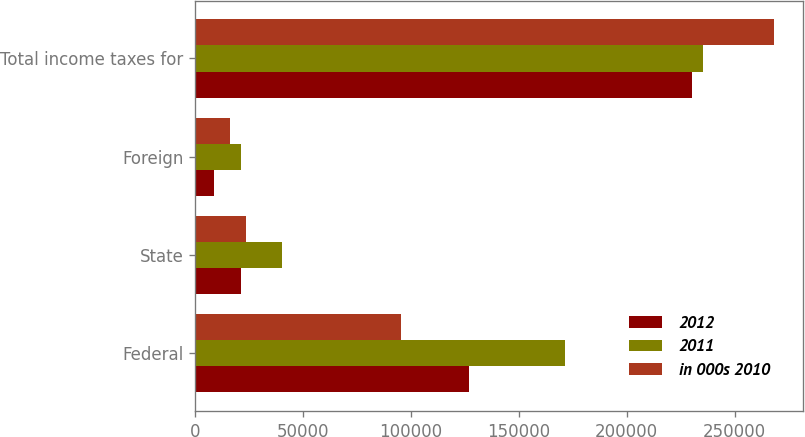Convert chart. <chart><loc_0><loc_0><loc_500><loc_500><stacked_bar_chart><ecel><fcel>Federal<fcel>State<fcel>Foreign<fcel>Total income taxes for<nl><fcel>2012<fcel>126773<fcel>21285<fcel>8647<fcel>230102<nl><fcel>2011<fcel>171337<fcel>40433<fcel>21456<fcel>235156<nl><fcel>in 000s 2010<fcel>95473<fcel>23674<fcel>16331<fcel>268291<nl></chart> 